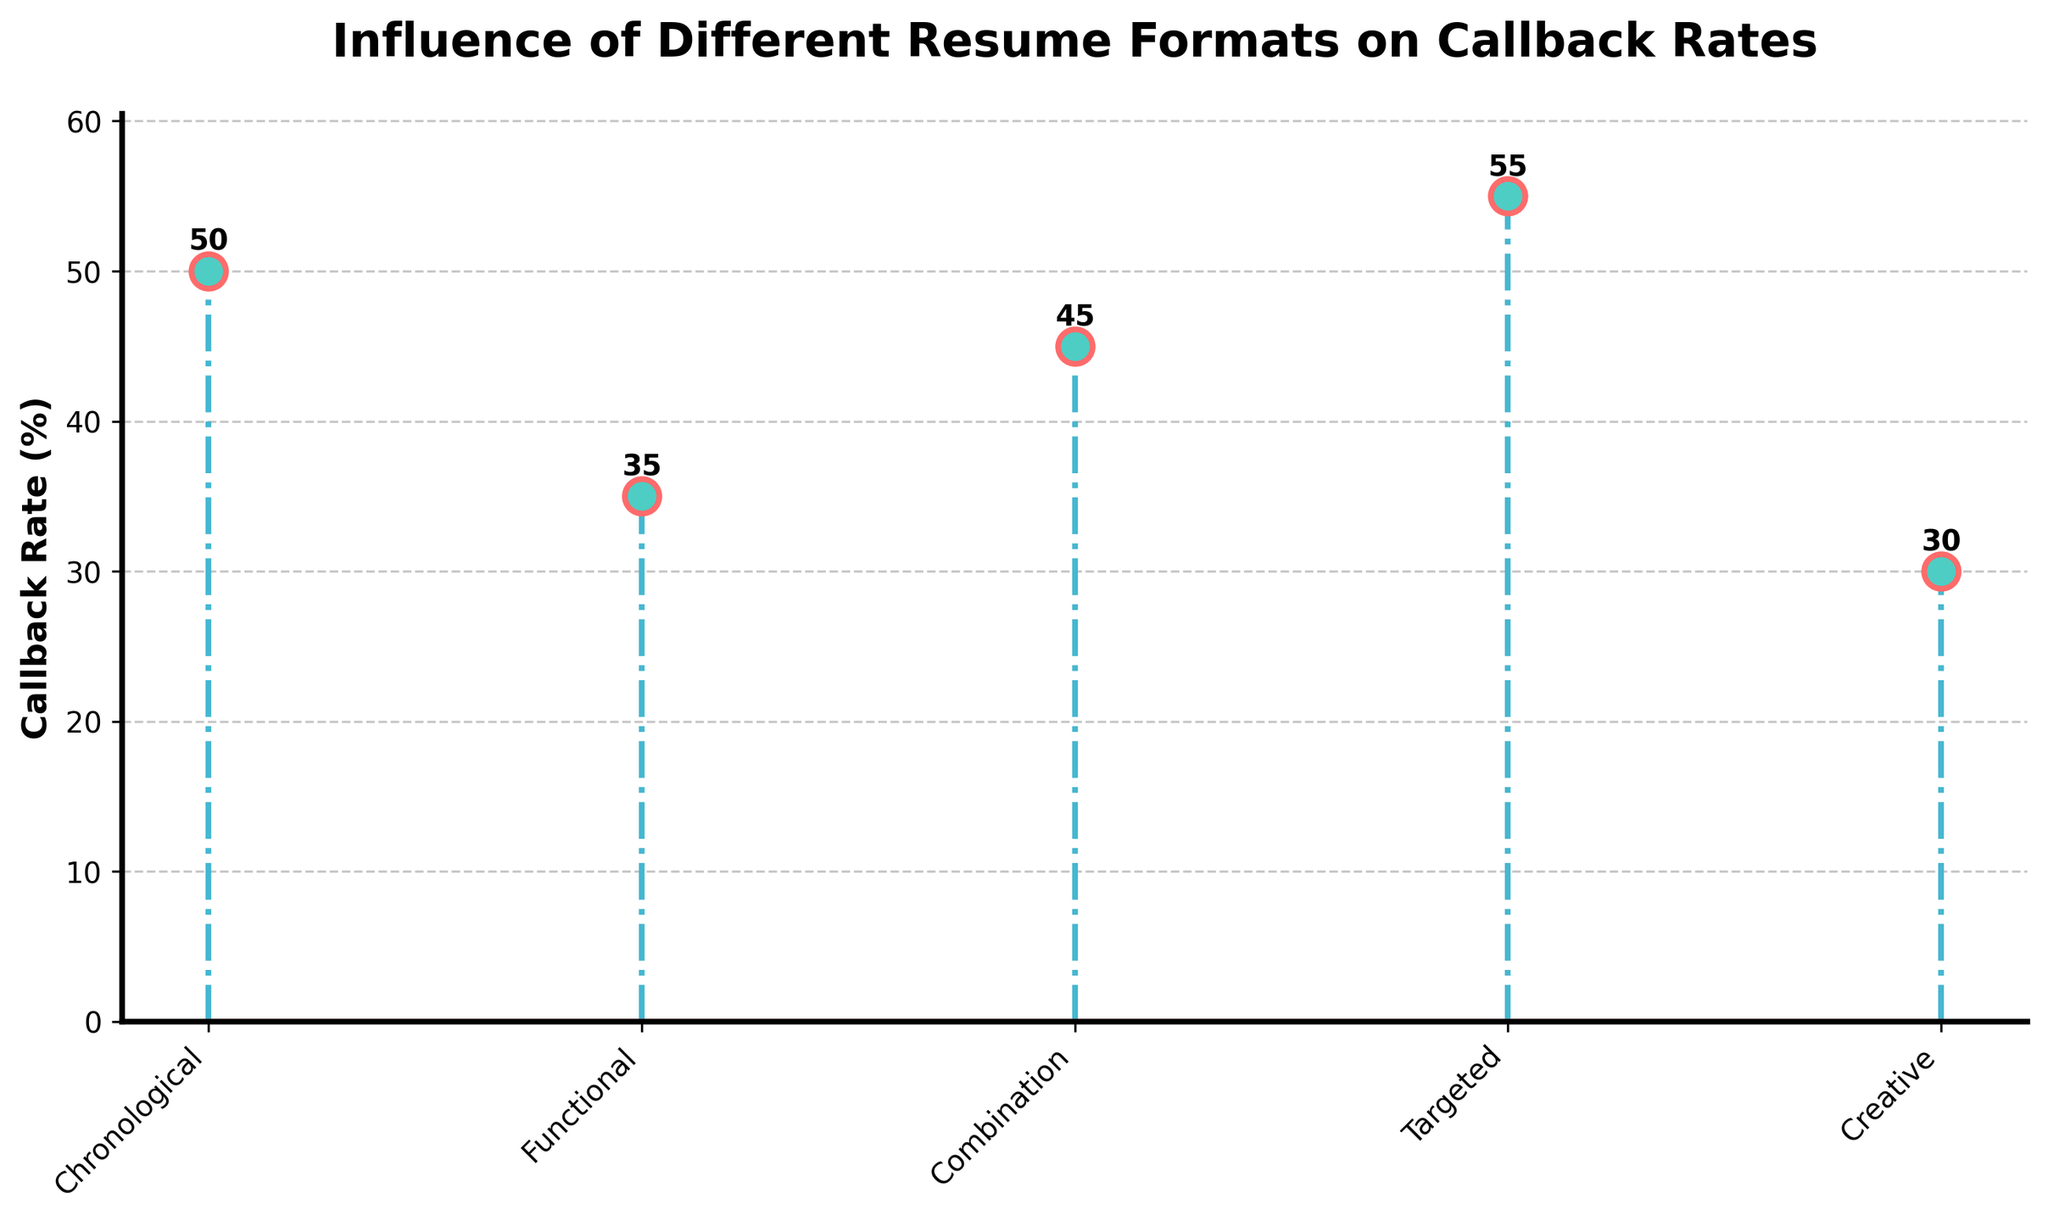What's the title of the chart? The title of the chart is displayed at the top in bold text.
Answer: Influence of Different Resume Formats on Callback Rates What's the highest callback rate and which resume format does it correspond to? The highest point on the y-axis indicates the highest callback rate, and its corresponding x-axis label tells us the resume format. The highest callback rate is 55%, which corresponds to the Targeted resume format.
Answer: 55%, Targeted What's the callback rate for the Creative resume format? Look at the point on the chart that corresponds to "Creative" on the x-axis and read its height on the y-axis.
Answer: 30% Which resume format has the second highest callback rate? Identify the second tallest point on the y-axis and find the corresponding x-axis label. The second highest callback rate is 50%, which corresponds to the Chronological resume format.
Answer: Chronological What is the difference in callback rate between the chronology and the functional resume formats? Subtract the callback rate of the Functional resume format from that of the Chronological resume format. 50% - 35% = 15%.
Answer: 15% What is the average callback rate for all resume formats? Add all the callback rates and divide by the number of formats: (50 + 35 + 45 + 55 + 30) / 5 = 43%.
Answer: 43% Which resume format has the lowest callback rate? Identify the shortest point on the y-axis and find the corresponding x-axis label. The lowest callback rate is 30% for the Creative resume format.
Answer: Creative Do any two resume formats have equal callback rates? Look at the heights of each point and see if any two are the same. Since no two points share the same height, no two resume formats have equal callback rates.
Answer: No What's the difference between the highest and lowest callback rates? Subtract the lowest callback rate from the highest callback rate. 55% - 30% = 25%.
Answer: 25% Which resume formats have a callback rate greater than 40%? Look at the points with a y-value greater than 40% and identify their corresponding x-axis labels. The formats are Chronological (50%), Combination (45%), and Targeted (55%).
Answer: Chronological, Combination, Targeted 